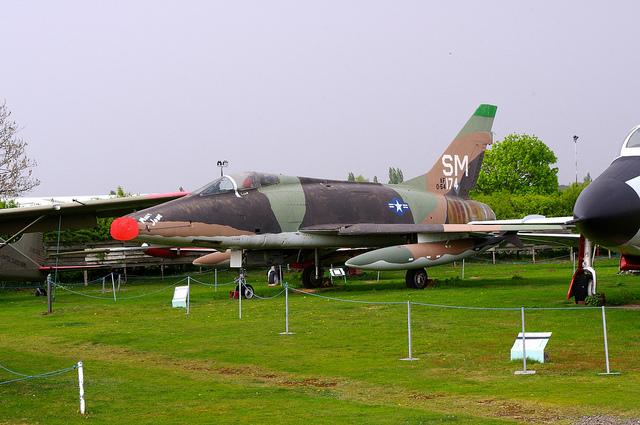What are the letters on the tail of the plane?
Short answer required. Sm. What would this plane be used for?
Keep it brief. Military. Where is this photo taken?
Keep it brief. Airplane museum. 